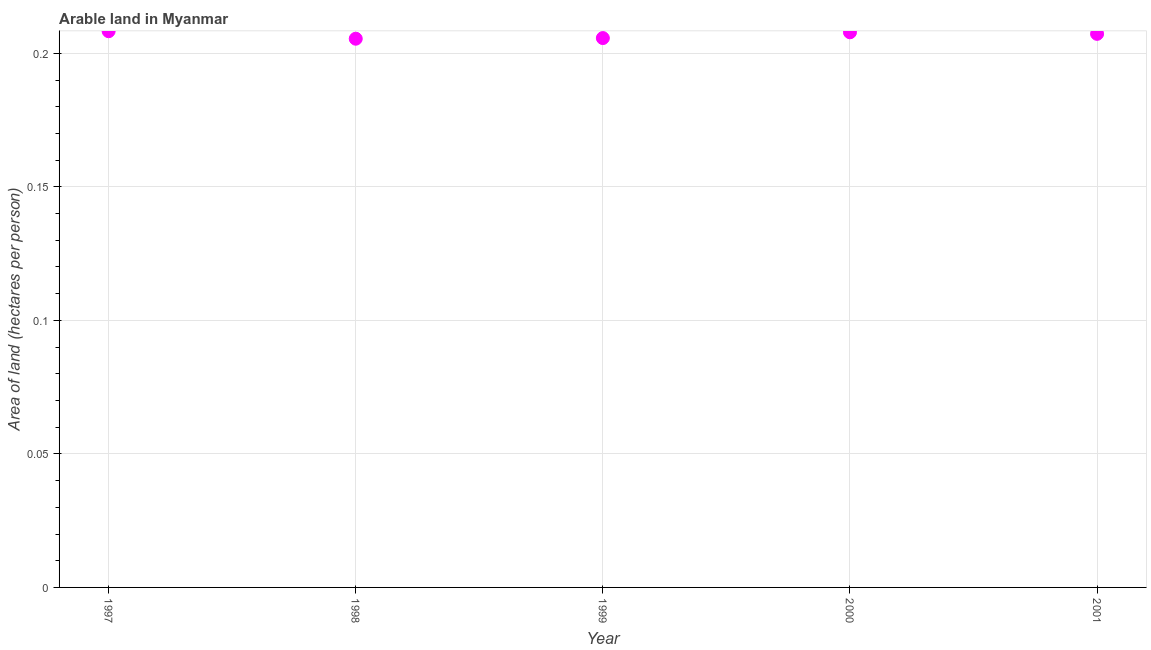What is the area of arable land in 1997?
Offer a terse response. 0.21. Across all years, what is the maximum area of arable land?
Give a very brief answer. 0.21. Across all years, what is the minimum area of arable land?
Your answer should be very brief. 0.21. In which year was the area of arable land maximum?
Offer a terse response. 1997. In which year was the area of arable land minimum?
Offer a terse response. 1998. What is the sum of the area of arable land?
Make the answer very short. 1.03. What is the difference between the area of arable land in 1998 and 2000?
Give a very brief answer. -0. What is the average area of arable land per year?
Your answer should be very brief. 0.21. What is the median area of arable land?
Ensure brevity in your answer.  0.21. In how many years, is the area of arable land greater than 0.1 hectares per person?
Provide a succinct answer. 5. What is the ratio of the area of arable land in 1999 to that in 2000?
Provide a succinct answer. 0.99. Is the area of arable land in 1998 less than that in 2001?
Ensure brevity in your answer.  Yes. What is the difference between the highest and the second highest area of arable land?
Your answer should be very brief. 0. What is the difference between the highest and the lowest area of arable land?
Give a very brief answer. 0. Does the area of arable land monotonically increase over the years?
Ensure brevity in your answer.  No. How many dotlines are there?
Ensure brevity in your answer.  1. How many years are there in the graph?
Ensure brevity in your answer.  5. What is the difference between two consecutive major ticks on the Y-axis?
Your answer should be very brief. 0.05. Are the values on the major ticks of Y-axis written in scientific E-notation?
Give a very brief answer. No. What is the title of the graph?
Offer a terse response. Arable land in Myanmar. What is the label or title of the Y-axis?
Offer a terse response. Area of land (hectares per person). What is the Area of land (hectares per person) in 1997?
Make the answer very short. 0.21. What is the Area of land (hectares per person) in 1998?
Your answer should be very brief. 0.21. What is the Area of land (hectares per person) in 1999?
Give a very brief answer. 0.21. What is the Area of land (hectares per person) in 2000?
Offer a very short reply. 0.21. What is the Area of land (hectares per person) in 2001?
Keep it short and to the point. 0.21. What is the difference between the Area of land (hectares per person) in 1997 and 1998?
Your answer should be very brief. 0. What is the difference between the Area of land (hectares per person) in 1997 and 1999?
Provide a short and direct response. 0. What is the difference between the Area of land (hectares per person) in 1997 and 2000?
Give a very brief answer. 0. What is the difference between the Area of land (hectares per person) in 1997 and 2001?
Your answer should be very brief. 0. What is the difference between the Area of land (hectares per person) in 1998 and 1999?
Give a very brief answer. -0. What is the difference between the Area of land (hectares per person) in 1998 and 2000?
Your answer should be very brief. -0. What is the difference between the Area of land (hectares per person) in 1998 and 2001?
Your answer should be very brief. -0. What is the difference between the Area of land (hectares per person) in 1999 and 2000?
Your response must be concise. -0. What is the difference between the Area of land (hectares per person) in 1999 and 2001?
Your response must be concise. -0. What is the difference between the Area of land (hectares per person) in 2000 and 2001?
Offer a terse response. 0. What is the ratio of the Area of land (hectares per person) in 1997 to that in 2000?
Give a very brief answer. 1. What is the ratio of the Area of land (hectares per person) in 1997 to that in 2001?
Offer a very short reply. 1. What is the ratio of the Area of land (hectares per person) in 1998 to that in 2001?
Provide a short and direct response. 0.99. What is the ratio of the Area of land (hectares per person) in 1999 to that in 2001?
Your answer should be very brief. 0.99. 